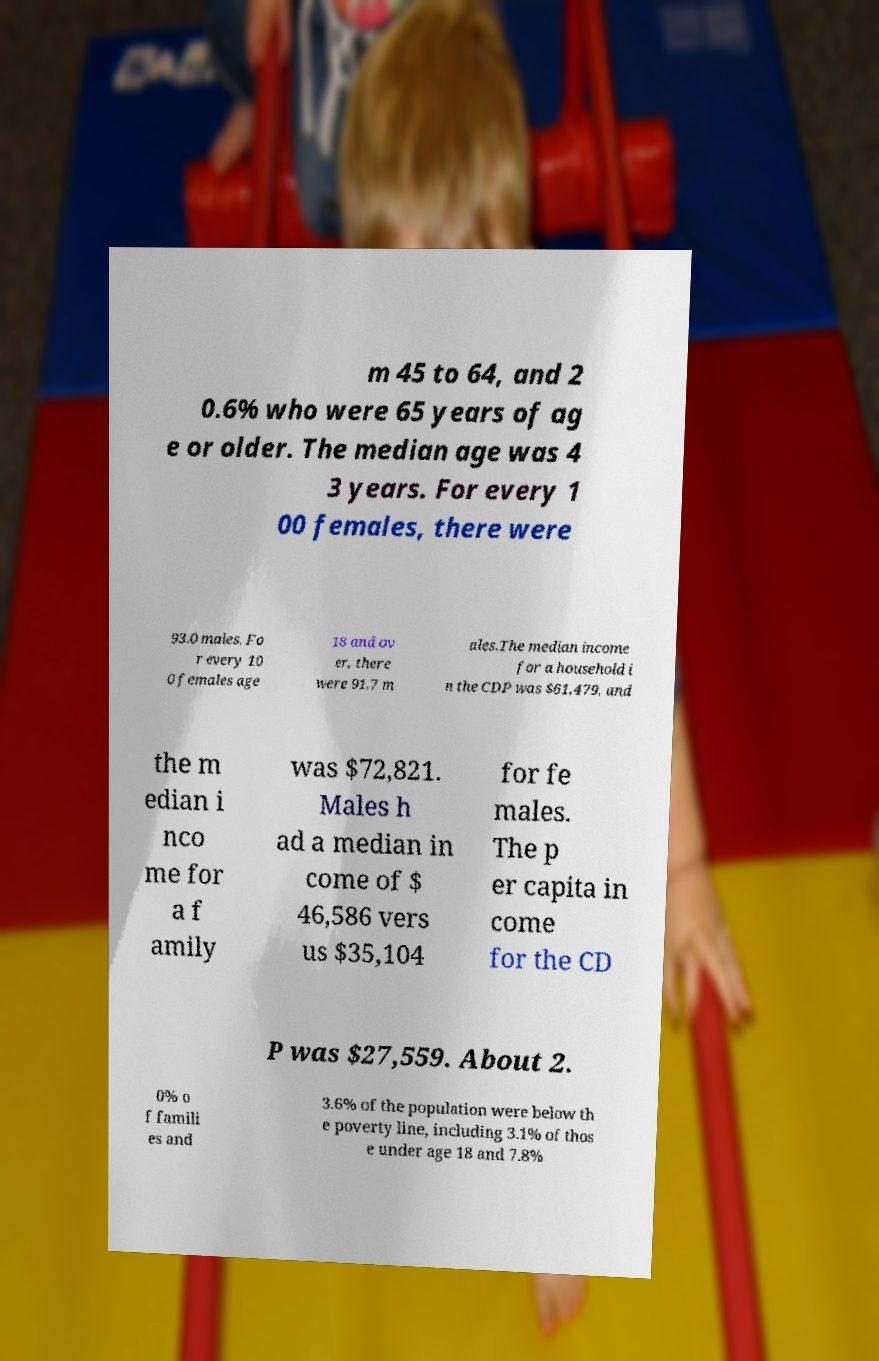There's text embedded in this image that I need extracted. Can you transcribe it verbatim? m 45 to 64, and 2 0.6% who were 65 years of ag e or older. The median age was 4 3 years. For every 1 00 females, there were 93.0 males. Fo r every 10 0 females age 18 and ov er, there were 91.7 m ales.The median income for a household i n the CDP was $61,479, and the m edian i nco me for a f amily was $72,821. Males h ad a median in come of $ 46,586 vers us $35,104 for fe males. The p er capita in come for the CD P was $27,559. About 2. 0% o f famili es and 3.6% of the population were below th e poverty line, including 3.1% of thos e under age 18 and 7.8% 